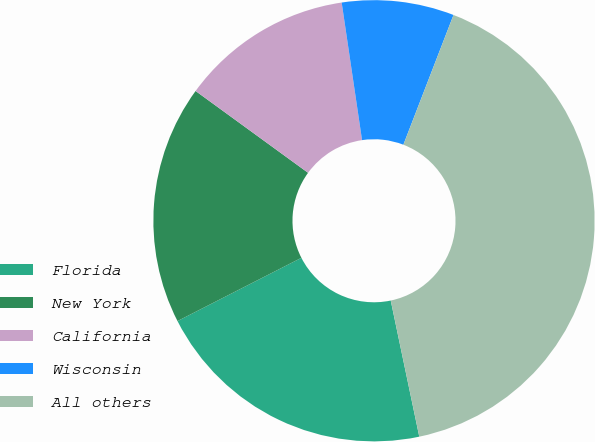<chart> <loc_0><loc_0><loc_500><loc_500><pie_chart><fcel>Florida<fcel>New York<fcel>California<fcel>Wisconsin<fcel>All others<nl><fcel>20.78%<fcel>17.52%<fcel>12.65%<fcel>8.21%<fcel>40.84%<nl></chart> 